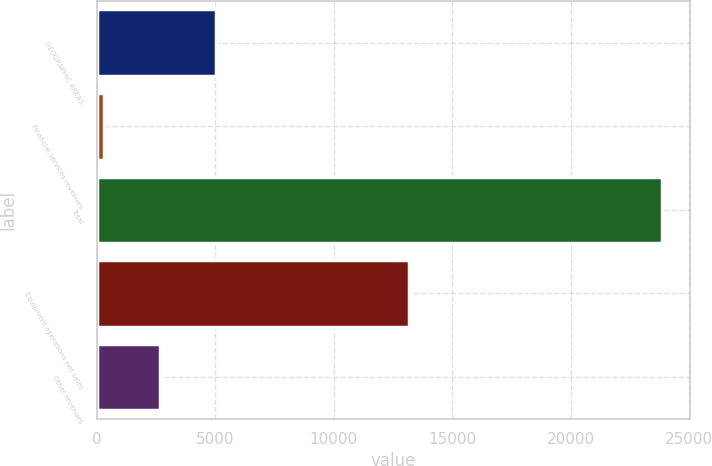Convert chart to OTSL. <chart><loc_0><loc_0><loc_500><loc_500><bar_chart><fcel>GEOGRAPHIC AREAS<fcel>Financial services revenues<fcel>Total<fcel>Equipment operations net sales<fcel>Other revenues<nl><fcel>5024.8<fcel>318<fcel>23852<fcel>13177<fcel>2671.4<nl></chart> 